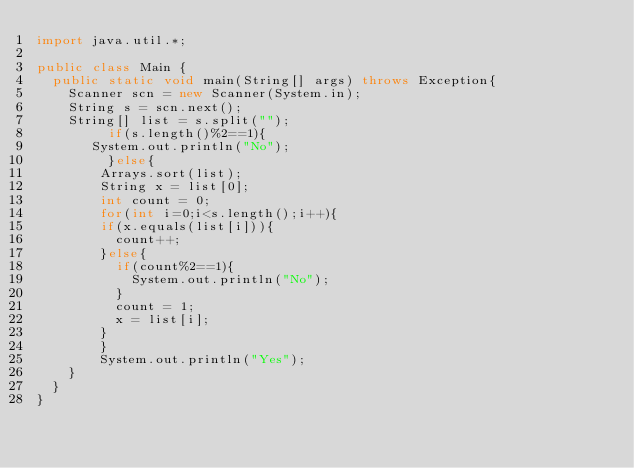Convert code to text. <code><loc_0><loc_0><loc_500><loc_500><_Java_>import java.util.*;

public class Main {
	public static void main(String[] args) throws Exception{
		Scanner scn = new Scanner(System.in);
		String s = scn.next();
		String[] list = s.split("");
      	 if(s.length()%2==1){
     	 System.out.println("No");
         }else{
      	Arrays.sort(list);
      	String x = list[0];
      	int count = 0;
      	for(int i=0;i<s.length();i++){
        if(x.equals(list[i])){
          count++;
        }else{
          if(count%2==1){
            System.out.println("No");
          }
          count = 1;
          x = list[i];
        }
        }
      	System.out.println("Yes");
    }
	}
}
</code> 